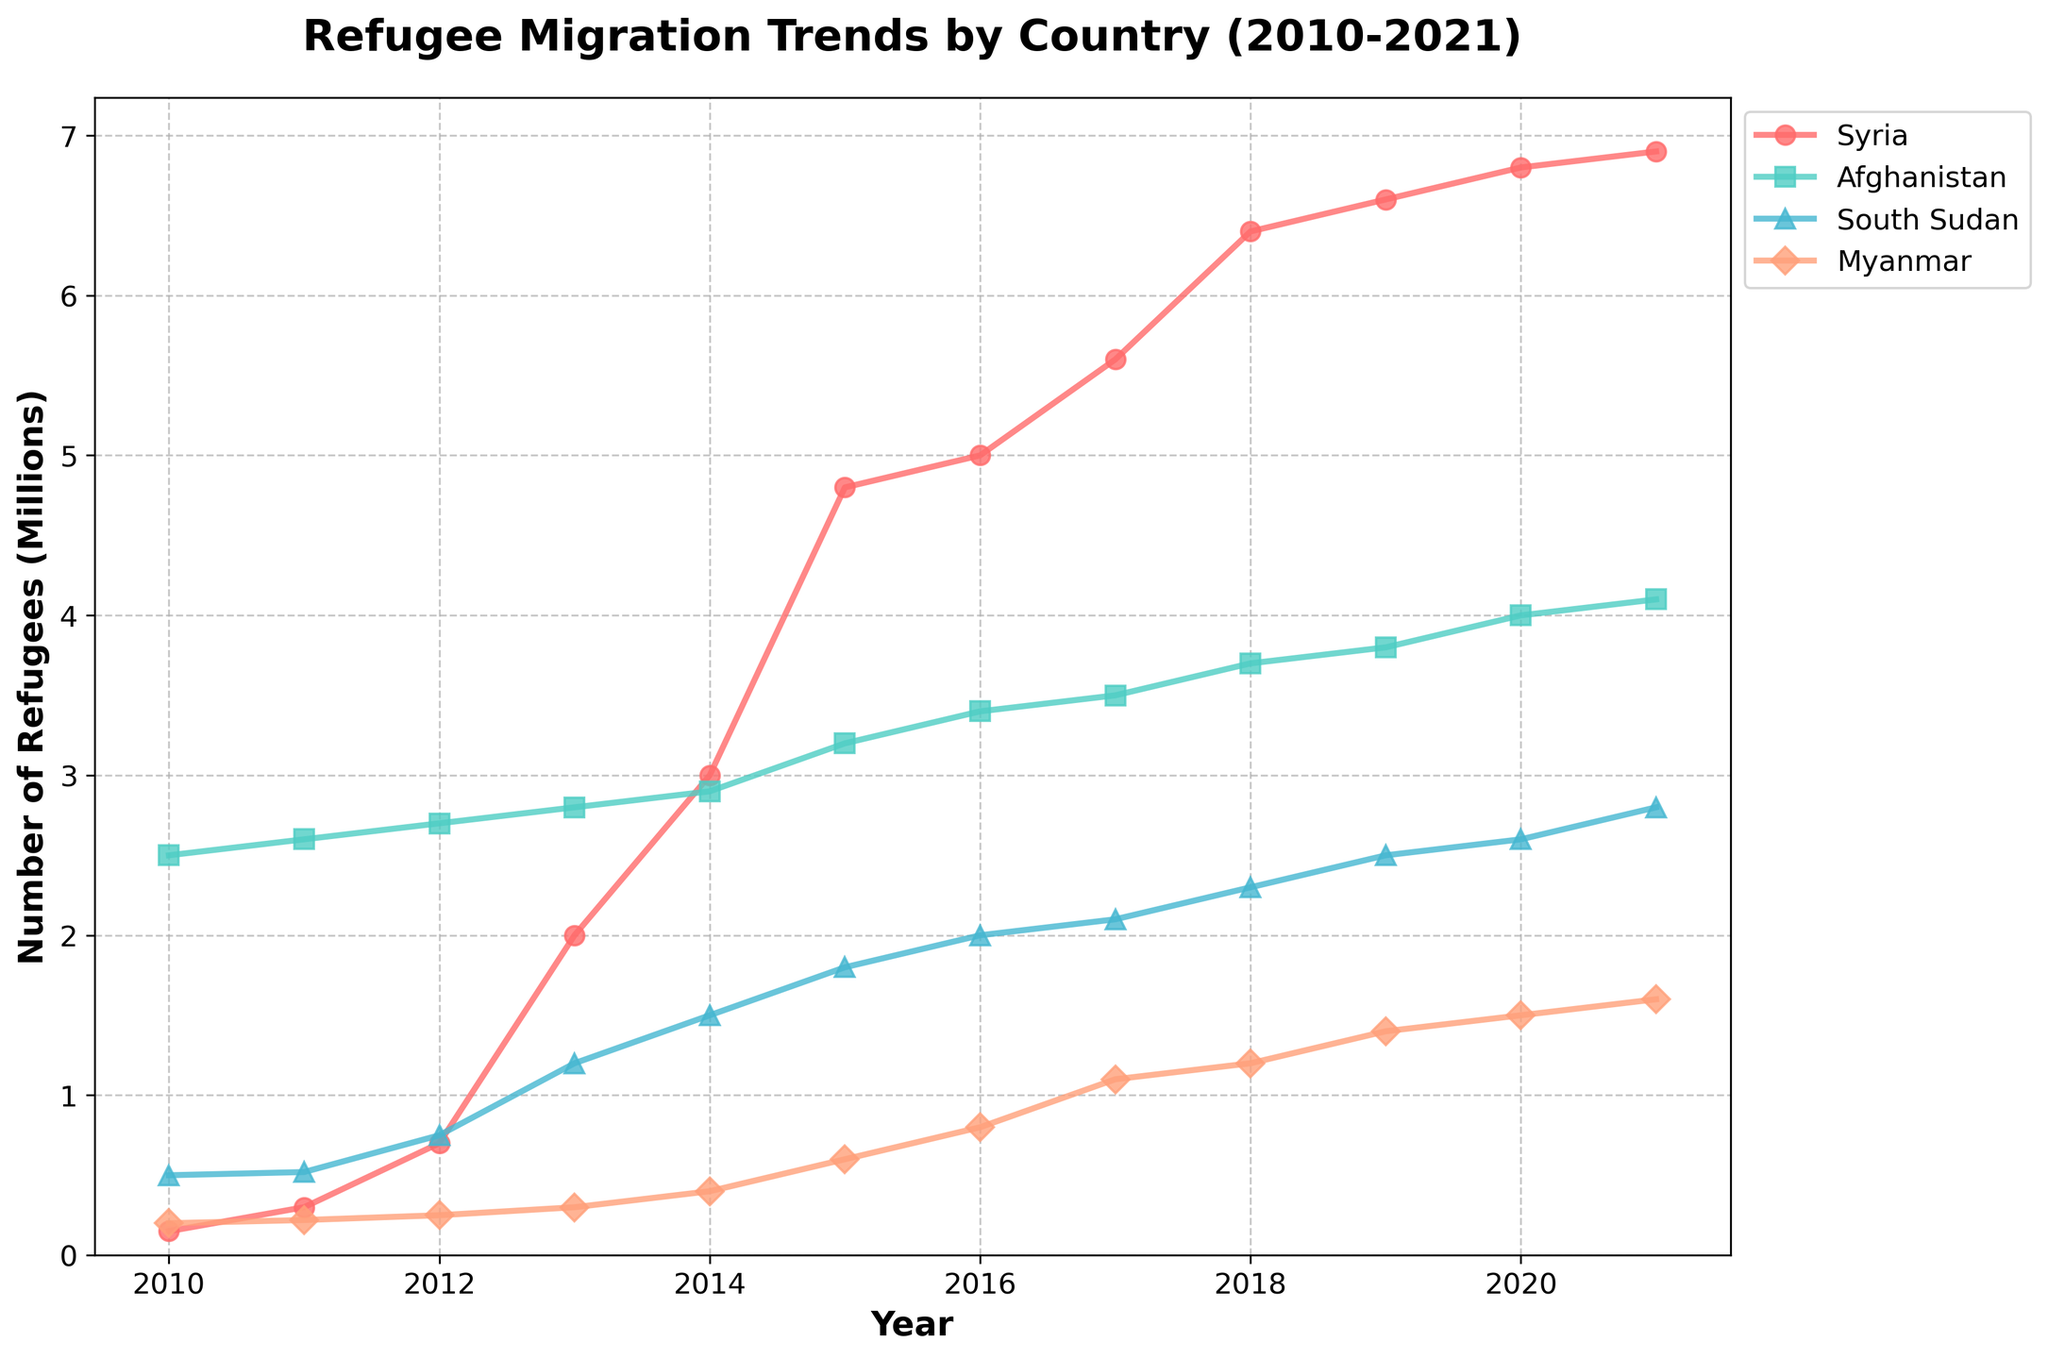What does the title of the plot indicate? The title "Refugee Migration Trends by Country (2010-2021)" suggests that the figure depicts the changes in the number of refugees from various countries over the period 2010 to 2021. The title specifies both the subject (refugee migration) and the timeframe (2010-2021).
Answer: Refugee Migration Trends by Country (2010-2021) What is the general trend for refugee numbers from Syria between 2010 and 2021? Referring to the trendline for Syria, the number of refugees increases sharply from 150,000 in 2010 to approximately 6.9 million by 2021, indicating a significant and consistent upward trend over the years.
Answer: Increasing trend Which country has the highest number of refugees by 2021? By examining the rightmost data points (2021) for all countries, Syria has the highest number, with around 6.9 million refugees.
Answer: Syria How does the growth in refugee numbers for Afghanistan compare to Myanmar between 2010 and 2021? Between 2010 and 2021, the number of refugees from Afghanistan increases from 2.5 million to 4.1 million, while for Myanmar, it increases from 200,000 to 1.6 million. Afghanistan has a higher absolute increase in refugee numbers, but Myanmar has a higher relative growth.
Answer: Afghanistan (higher absolute increase), Myanmar (higher relative growth) What are the regions represented in the plot, and which color corresponds to each country? The regions are Middle East, South Asia, Africa, and Southeast Asia. Syria (Middle East) is represented by a red line, Afghanistan (South Asia) by a turquoise line, South Sudan (Africa) by a blue line, and Myanmar (Southeast Asia) by an orange line.
Answer: Middle East (red), South Asia (turquoise), Africa (blue), Southeast Asia (orange) What specific year does Syria see the highest increase in refugee numbers? By looking at the steepest slope on the Syria trendline, the most significant annual increase occurs between 2012 and 2013, where the number jumps from 700,000 to 2 million.
Answer: 2013 Compare the refugee trends for South Sudan and Myanmar. Which country shows a more rapid increase in refugee numbers from 2013 onwards? After 2013, South Sudan increases from about 1.2 million to 2.8 million by 2021, while Myanmar rises from 300,000 to 1.6 million. South Sudan demonstrates a more rapid numerical increase during this period.
Answer: South Sudan Calculate the total number of refugees from all four countries in 2021. Sum the 2021 values for Syria (6.9 million), Afghanistan (4.1 million), South Sudan (2.8 million), and Myanmar (1.6 million). Adding these, we get 6.9 + 4.1 + 2.8 + 1.6 = 15.4 million.
Answer: 15.4 million Which country has the least number of refugees throughout the entire period? By examining the trendlines, Myanmar consistently has fewer refugees compared to Syria, Afghanistan, and South Sudan, from 2010 (200,000) to 2021 (1.6 million).
Answer: Myanmar What year do Afghanistan and South Sudan have approximately equal numbers of refugees? Checking the overlapping points of the lines, in the year 2010, both Afghanistan and South Sudan have nearly equal refugee numbers, with Afghanistan at 2.5 million and South Sudan at 0.5 million. So it appears there's no year exactly overlapping; hence, specific relative comparisons vary.
Answer: No exact year 